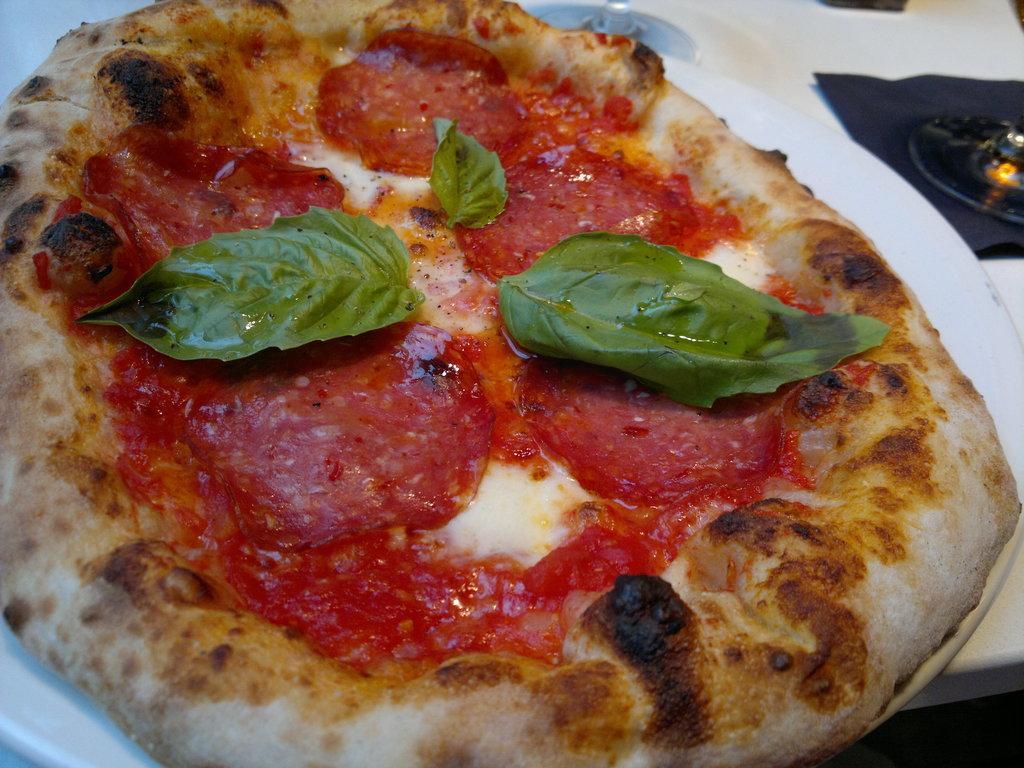Could you give a brief overview of what you see in this image? In the image in the center, we can see one table. On the table, we can see one cloth, plate and a few other objects. In the plate, we can see one pizza. 